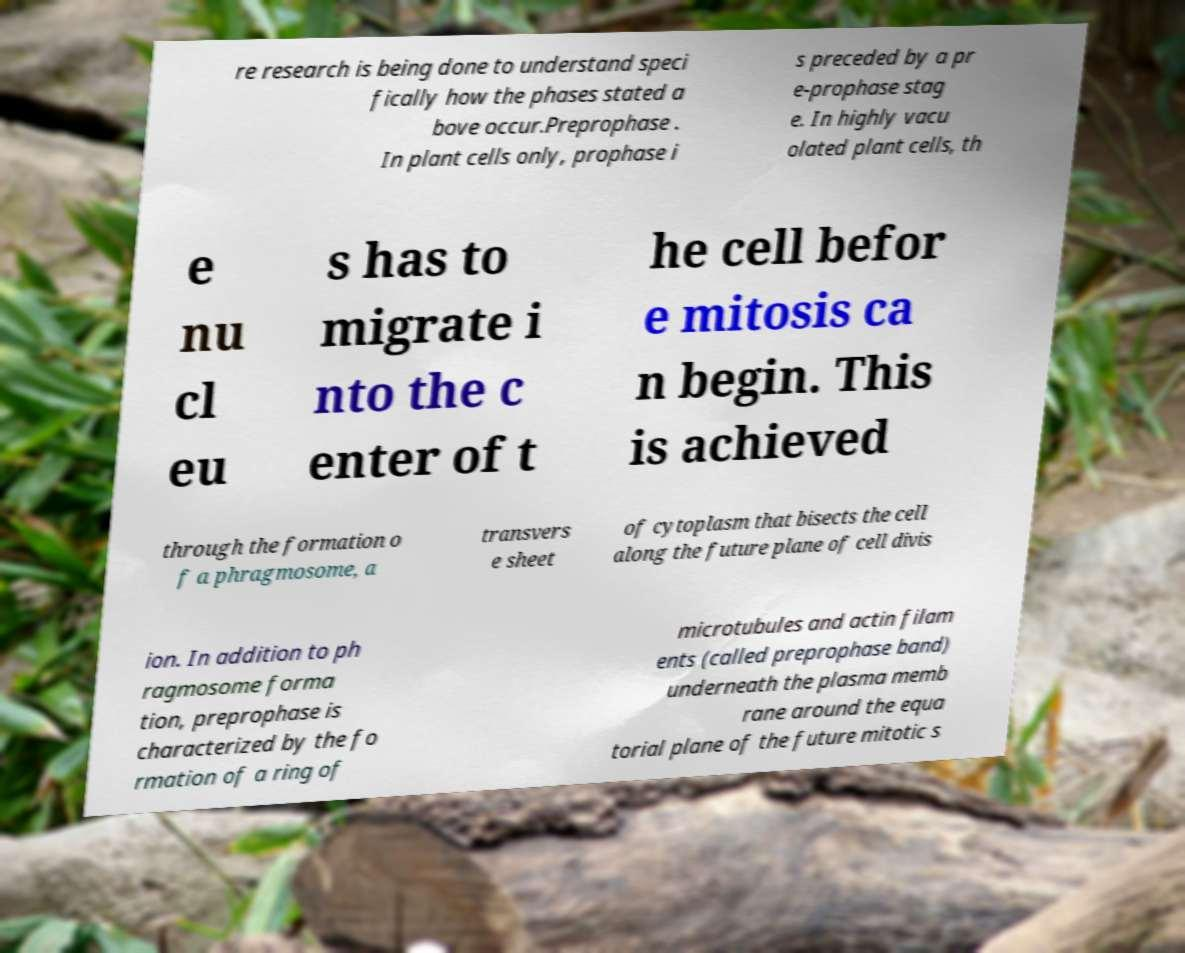Can you read and provide the text displayed in the image?This photo seems to have some interesting text. Can you extract and type it out for me? re research is being done to understand speci fically how the phases stated a bove occur.Preprophase . In plant cells only, prophase i s preceded by a pr e-prophase stag e. In highly vacu olated plant cells, th e nu cl eu s has to migrate i nto the c enter of t he cell befor e mitosis ca n begin. This is achieved through the formation o f a phragmosome, a transvers e sheet of cytoplasm that bisects the cell along the future plane of cell divis ion. In addition to ph ragmosome forma tion, preprophase is characterized by the fo rmation of a ring of microtubules and actin filam ents (called preprophase band) underneath the plasma memb rane around the equa torial plane of the future mitotic s 